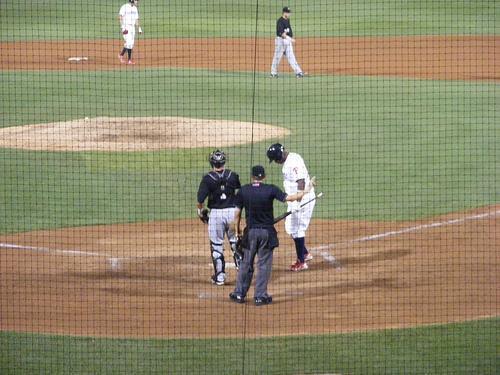How many men are on the field?
Give a very brief answer. 5. How many bats are visible in this photo?
Give a very brief answer. 1. 